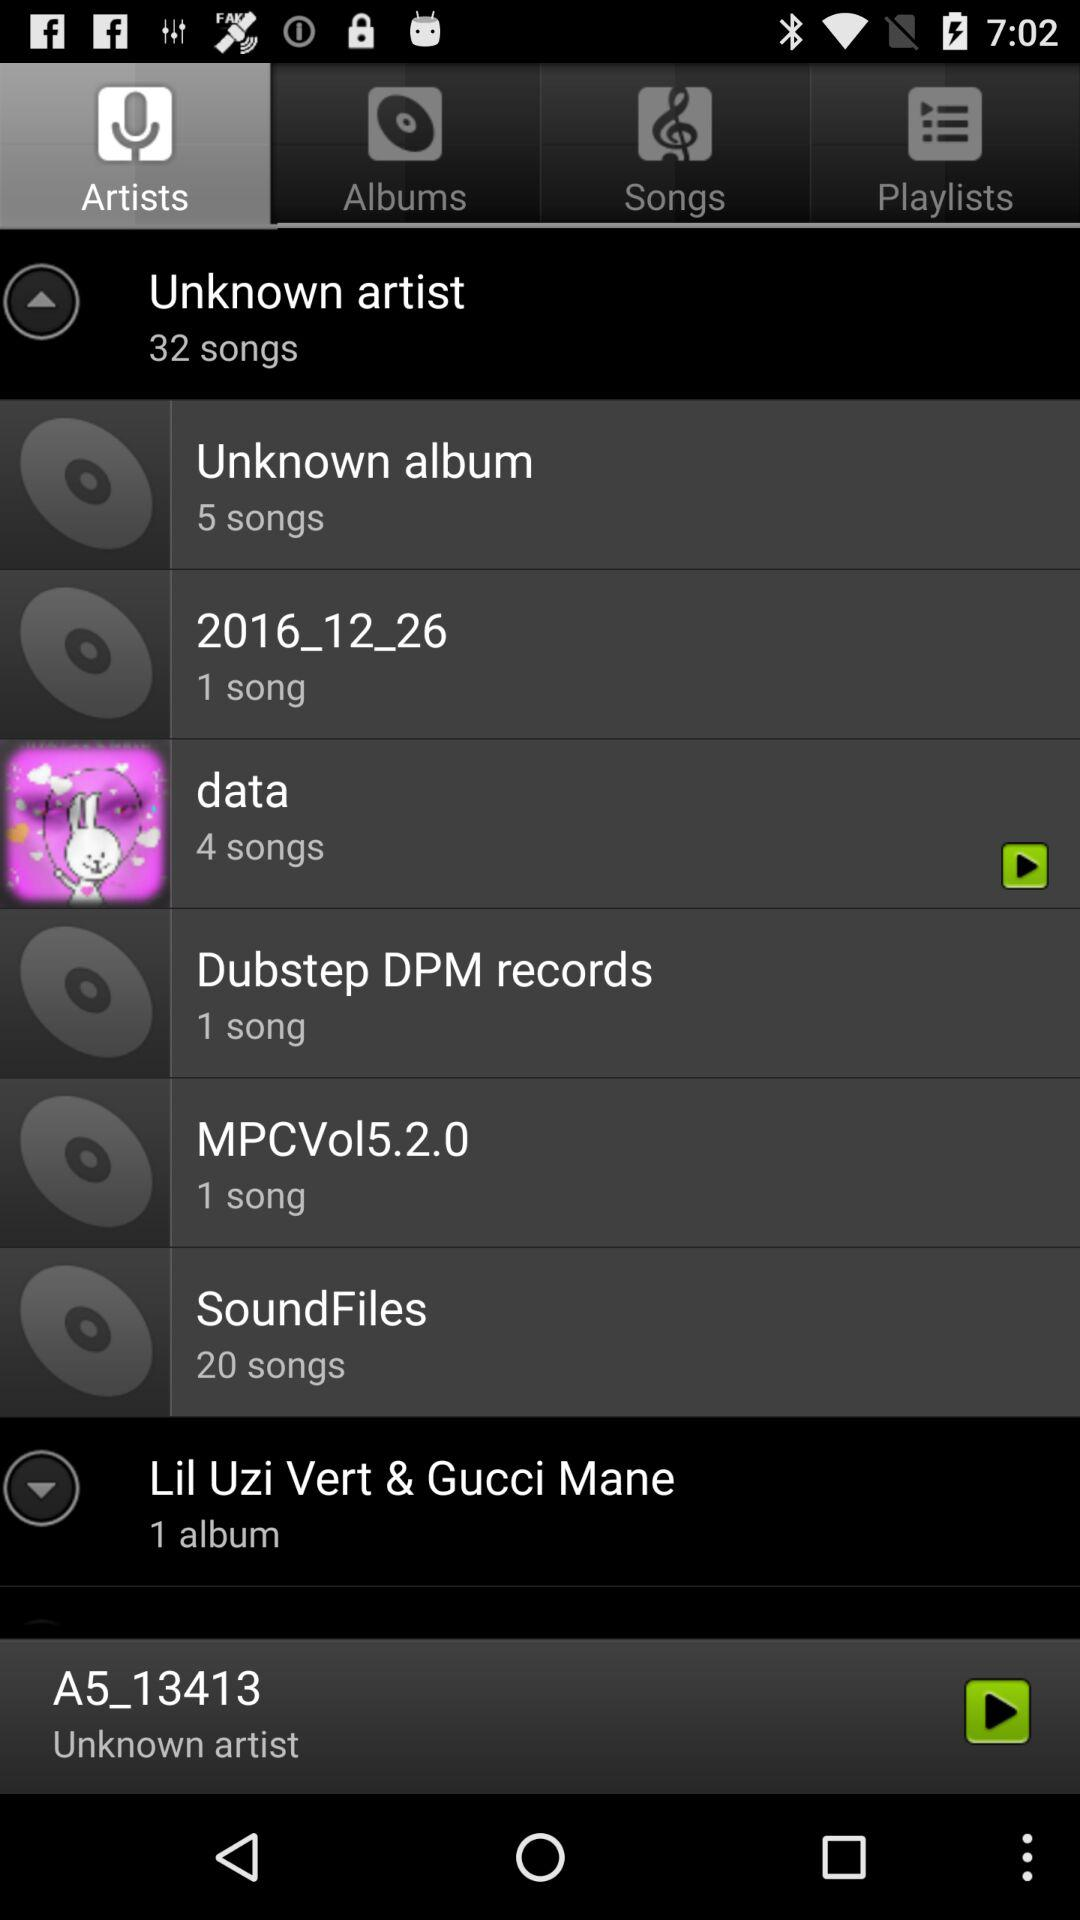How many songs are in the album with the most songs?
Answer the question using a single word or phrase. 20 